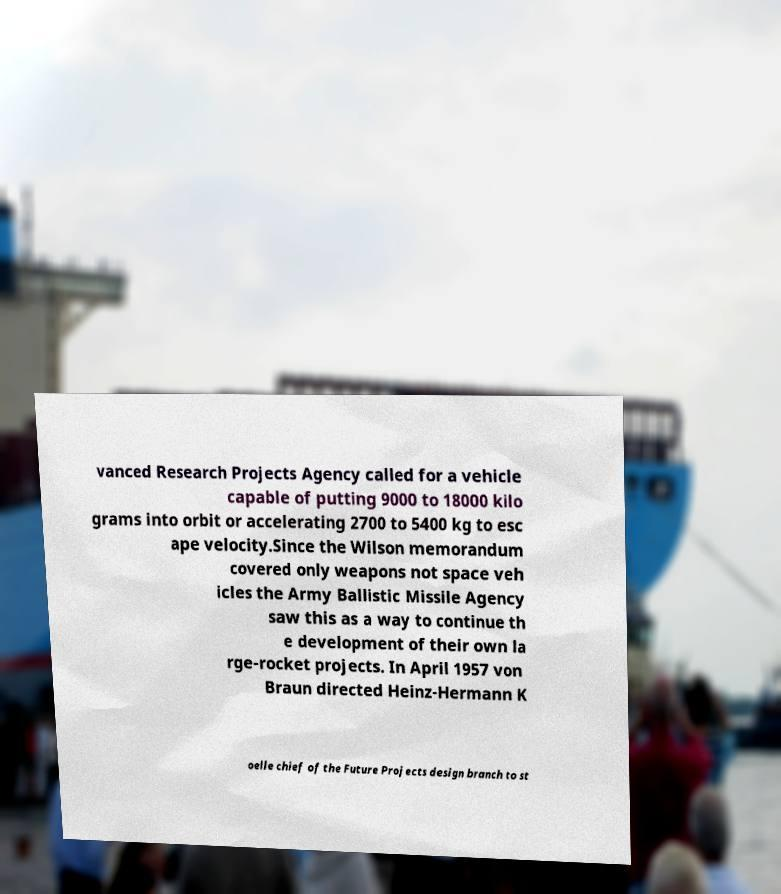There's text embedded in this image that I need extracted. Can you transcribe it verbatim? vanced Research Projects Agency called for a vehicle capable of putting 9000 to 18000 kilo grams into orbit or accelerating 2700 to 5400 kg to esc ape velocity.Since the Wilson memorandum covered only weapons not space veh icles the Army Ballistic Missile Agency saw this as a way to continue th e development of their own la rge-rocket projects. In April 1957 von Braun directed Heinz-Hermann K oelle chief of the Future Projects design branch to st 